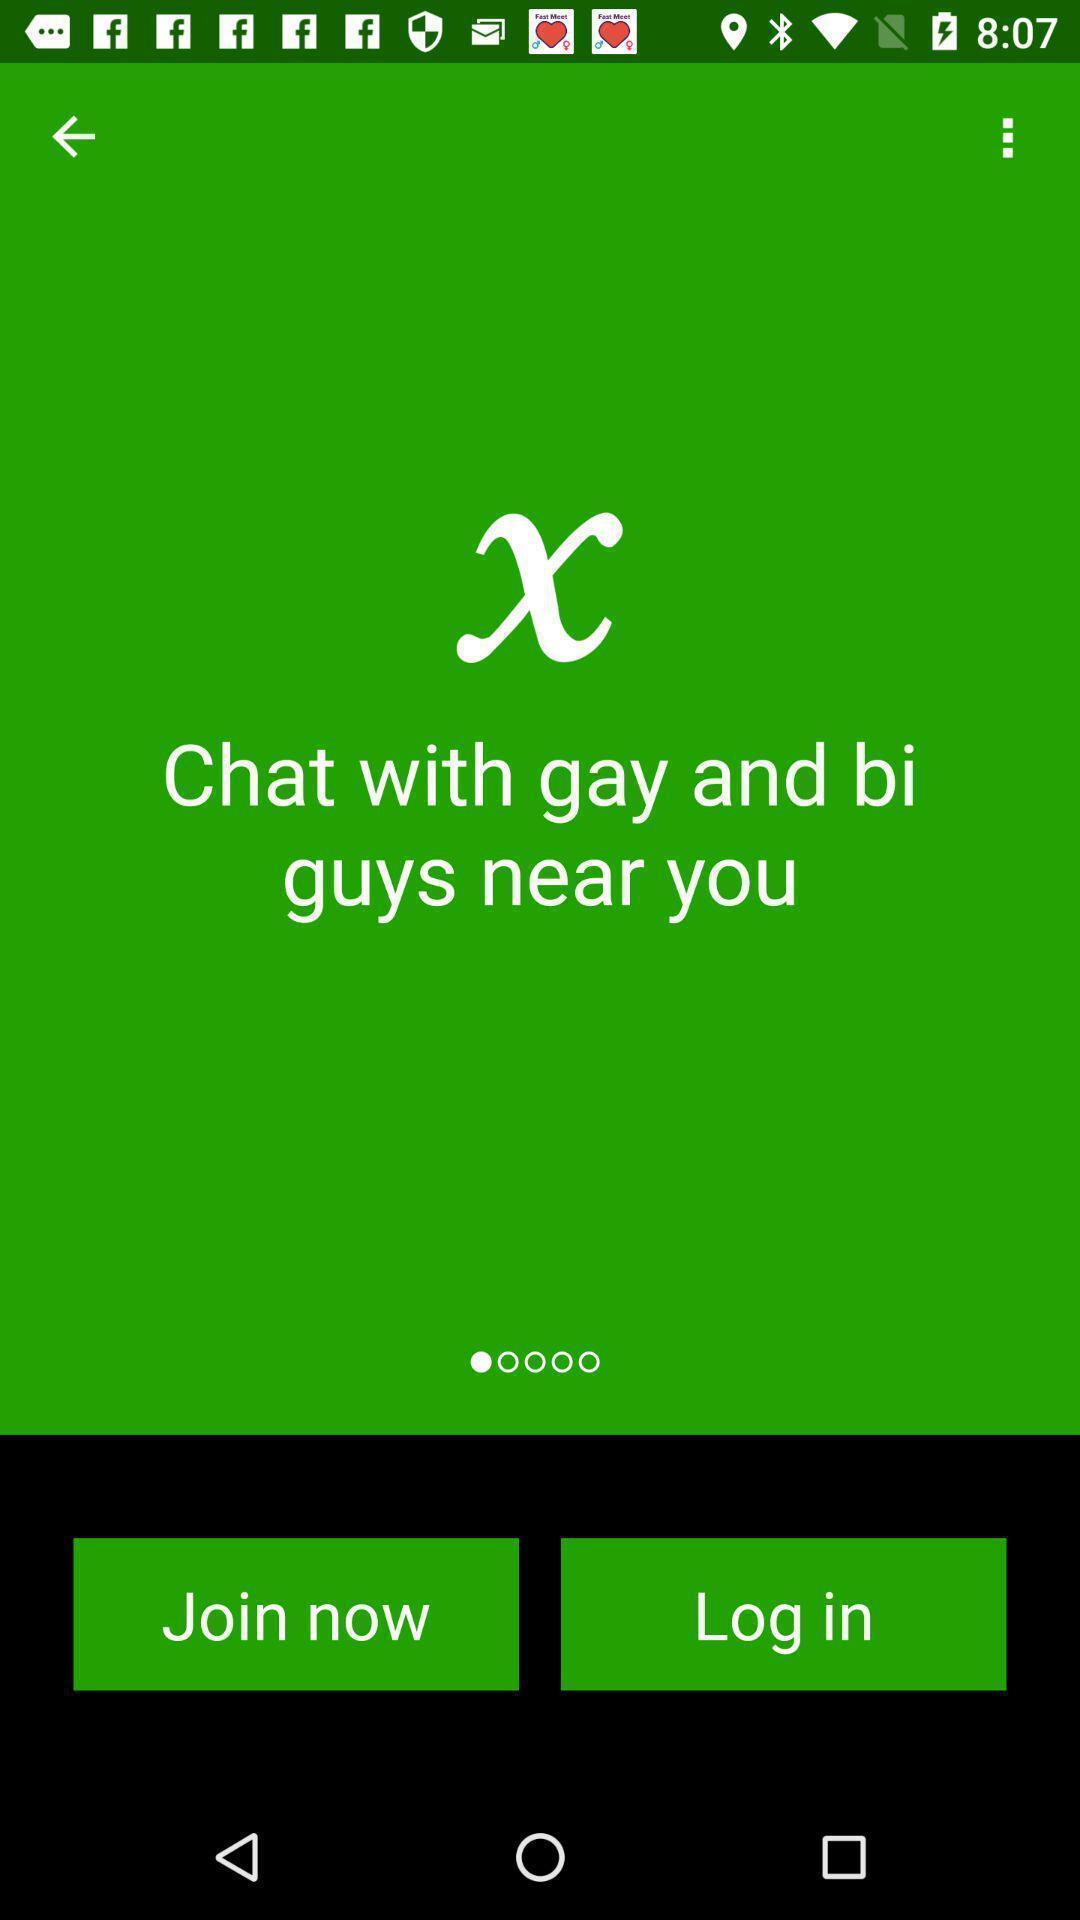Summarize the main components in this picture. Page showing login page. 